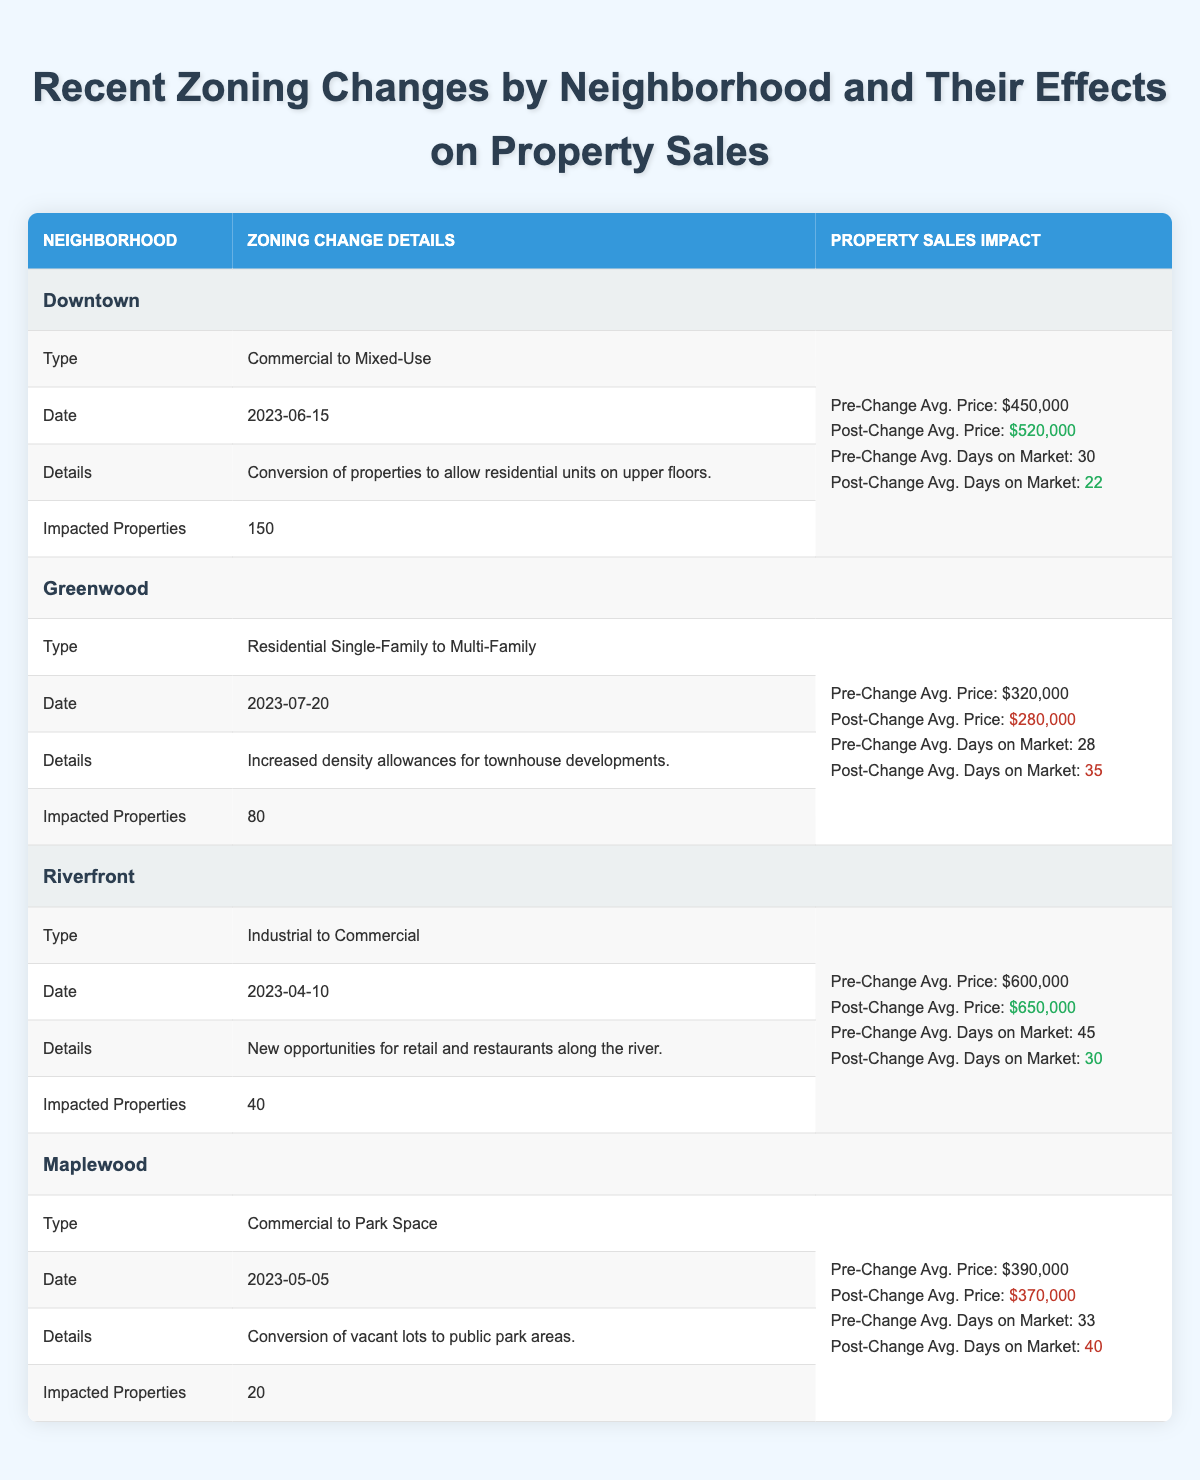What was the zoning change type for Downtown? The specific zoning change type for Downtown is listed under "Zoning Change Details" in the table, where it states "Commercial to Mixed-Use".
Answer: Commercial to Mixed-Use How many impacted properties were there in Greenwood? Looking at the Greenwood section of the table, under "Impacted Properties", the number is specified as 80.
Answer: 80 What was the average property sales price in Riverfront before the zoning change? The table shows under the Riverfront section that the "Pre-Change Avg. Price" is $600,000.
Answer: $600,000 Did the average days on the market increase or decrease in Downtown post-zoning change? In Downtown, the "Average Days on Market Pre-Change" is 30 days and "Post-Change Avg. Days on Market" is 22 days. Since 22 is less than 30, it indicates a decrease.
Answer: Decrease What was the percentage decrease in average property sales price in Greenwood after the zoning change? The pre-change average price in Greenwood is $320,000, and the post-change average price is $280,000. To calculate the percentage decrease: (320,000 - 280,000) / 320,000 * 100 = 12.5%.
Answer: 12.5% How many neighborhoods had an increase in the average property sales price after the zoning change? Analyzing the table, Downtown and Riverfront both show post-change prices higher than pre-change prices, while Greenwood and Maplewood show decreases. Thus, there are 2 neighborhoods with price increases.
Answer: 2 Was the zoning change in Maplewood beneficial for property sales based on the average prices? For Maplewood, the pre-change average price is $390,000, and the post-change average price is $370,000, indicating a decrease in average price after the change, which is generally not considered beneficial.
Answer: No What is the average reduction in days on market for neighborhoods with increased property sales prices? Only Downtown and Riverfront had increases in prices. For Downtown, the reduction is 30 - 22 = 8 days, and for Riverfront, it is 45 - 30 = 15 days. Average reduction: (8 + 15) / 2 = 11.5 days.
Answer: 11.5 days What was the date of the zoning change in Riverfront? The table under the Riverfront section notes the zoning change date as "2023-04-10".
Answer: 2023-04-10 